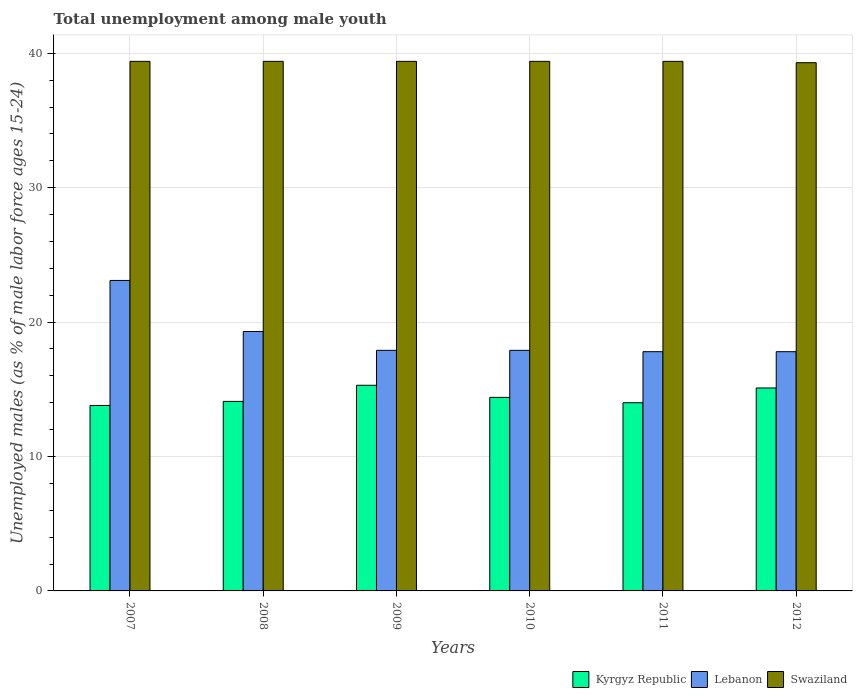How many different coloured bars are there?
Make the answer very short. 3. How many groups of bars are there?
Your answer should be compact. 6. How many bars are there on the 1st tick from the left?
Offer a terse response. 3. What is the percentage of unemployed males in in Kyrgyz Republic in 2010?
Your answer should be compact. 14.4. Across all years, what is the maximum percentage of unemployed males in in Swaziland?
Your response must be concise. 39.4. Across all years, what is the minimum percentage of unemployed males in in Lebanon?
Give a very brief answer. 17.8. In which year was the percentage of unemployed males in in Kyrgyz Republic maximum?
Offer a very short reply. 2009. What is the total percentage of unemployed males in in Kyrgyz Republic in the graph?
Provide a succinct answer. 86.7. What is the difference between the percentage of unemployed males in in Kyrgyz Republic in 2007 and the percentage of unemployed males in in Swaziland in 2012?
Your response must be concise. -25.5. What is the average percentage of unemployed males in in Swaziland per year?
Keep it short and to the point. 39.38. In the year 2010, what is the difference between the percentage of unemployed males in in Lebanon and percentage of unemployed males in in Swaziland?
Provide a succinct answer. -21.5. In how many years, is the percentage of unemployed males in in Swaziland greater than 18 %?
Provide a succinct answer. 6. What is the ratio of the percentage of unemployed males in in Kyrgyz Republic in 2007 to that in 2010?
Your response must be concise. 0.96. Is the percentage of unemployed males in in Lebanon in 2008 less than that in 2012?
Offer a terse response. No. What is the difference between the highest and the second highest percentage of unemployed males in in Kyrgyz Republic?
Keep it short and to the point. 0.2. What is the difference between the highest and the lowest percentage of unemployed males in in Lebanon?
Provide a short and direct response. 5.3. What does the 2nd bar from the left in 2009 represents?
Your answer should be very brief. Lebanon. What does the 1st bar from the right in 2008 represents?
Provide a short and direct response. Swaziland. Is it the case that in every year, the sum of the percentage of unemployed males in in Swaziland and percentage of unemployed males in in Lebanon is greater than the percentage of unemployed males in in Kyrgyz Republic?
Offer a very short reply. Yes. Are all the bars in the graph horizontal?
Offer a very short reply. No. What is the difference between two consecutive major ticks on the Y-axis?
Keep it short and to the point. 10. Are the values on the major ticks of Y-axis written in scientific E-notation?
Offer a very short reply. No. Does the graph contain any zero values?
Offer a very short reply. No. Where does the legend appear in the graph?
Provide a short and direct response. Bottom right. How are the legend labels stacked?
Ensure brevity in your answer.  Horizontal. What is the title of the graph?
Keep it short and to the point. Total unemployment among male youth. Does "Europe(developing only)" appear as one of the legend labels in the graph?
Offer a very short reply. No. What is the label or title of the X-axis?
Make the answer very short. Years. What is the label or title of the Y-axis?
Provide a succinct answer. Unemployed males (as % of male labor force ages 15-24). What is the Unemployed males (as % of male labor force ages 15-24) of Kyrgyz Republic in 2007?
Offer a very short reply. 13.8. What is the Unemployed males (as % of male labor force ages 15-24) in Lebanon in 2007?
Your answer should be compact. 23.1. What is the Unemployed males (as % of male labor force ages 15-24) in Swaziland in 2007?
Your answer should be very brief. 39.4. What is the Unemployed males (as % of male labor force ages 15-24) in Kyrgyz Republic in 2008?
Your answer should be compact. 14.1. What is the Unemployed males (as % of male labor force ages 15-24) of Lebanon in 2008?
Provide a succinct answer. 19.3. What is the Unemployed males (as % of male labor force ages 15-24) of Swaziland in 2008?
Ensure brevity in your answer.  39.4. What is the Unemployed males (as % of male labor force ages 15-24) of Kyrgyz Republic in 2009?
Ensure brevity in your answer.  15.3. What is the Unemployed males (as % of male labor force ages 15-24) of Lebanon in 2009?
Give a very brief answer. 17.9. What is the Unemployed males (as % of male labor force ages 15-24) of Swaziland in 2009?
Provide a short and direct response. 39.4. What is the Unemployed males (as % of male labor force ages 15-24) of Kyrgyz Republic in 2010?
Your response must be concise. 14.4. What is the Unemployed males (as % of male labor force ages 15-24) of Lebanon in 2010?
Make the answer very short. 17.9. What is the Unemployed males (as % of male labor force ages 15-24) of Swaziland in 2010?
Ensure brevity in your answer.  39.4. What is the Unemployed males (as % of male labor force ages 15-24) of Lebanon in 2011?
Ensure brevity in your answer.  17.8. What is the Unemployed males (as % of male labor force ages 15-24) of Swaziland in 2011?
Ensure brevity in your answer.  39.4. What is the Unemployed males (as % of male labor force ages 15-24) in Kyrgyz Republic in 2012?
Offer a very short reply. 15.1. What is the Unemployed males (as % of male labor force ages 15-24) in Lebanon in 2012?
Your response must be concise. 17.8. What is the Unemployed males (as % of male labor force ages 15-24) of Swaziland in 2012?
Your response must be concise. 39.3. Across all years, what is the maximum Unemployed males (as % of male labor force ages 15-24) of Kyrgyz Republic?
Your answer should be compact. 15.3. Across all years, what is the maximum Unemployed males (as % of male labor force ages 15-24) of Lebanon?
Ensure brevity in your answer.  23.1. Across all years, what is the maximum Unemployed males (as % of male labor force ages 15-24) in Swaziland?
Offer a terse response. 39.4. Across all years, what is the minimum Unemployed males (as % of male labor force ages 15-24) in Kyrgyz Republic?
Your response must be concise. 13.8. Across all years, what is the minimum Unemployed males (as % of male labor force ages 15-24) in Lebanon?
Keep it short and to the point. 17.8. Across all years, what is the minimum Unemployed males (as % of male labor force ages 15-24) of Swaziland?
Offer a terse response. 39.3. What is the total Unemployed males (as % of male labor force ages 15-24) of Kyrgyz Republic in the graph?
Provide a short and direct response. 86.7. What is the total Unemployed males (as % of male labor force ages 15-24) in Lebanon in the graph?
Your answer should be compact. 113.8. What is the total Unemployed males (as % of male labor force ages 15-24) of Swaziland in the graph?
Provide a short and direct response. 236.3. What is the difference between the Unemployed males (as % of male labor force ages 15-24) of Kyrgyz Republic in 2007 and that in 2008?
Make the answer very short. -0.3. What is the difference between the Unemployed males (as % of male labor force ages 15-24) of Lebanon in 2007 and that in 2008?
Offer a very short reply. 3.8. What is the difference between the Unemployed males (as % of male labor force ages 15-24) of Swaziland in 2007 and that in 2008?
Ensure brevity in your answer.  0. What is the difference between the Unemployed males (as % of male labor force ages 15-24) of Lebanon in 2007 and that in 2009?
Offer a very short reply. 5.2. What is the difference between the Unemployed males (as % of male labor force ages 15-24) in Swaziland in 2007 and that in 2009?
Your answer should be very brief. 0. What is the difference between the Unemployed males (as % of male labor force ages 15-24) in Kyrgyz Republic in 2007 and that in 2010?
Your answer should be very brief. -0.6. What is the difference between the Unemployed males (as % of male labor force ages 15-24) in Lebanon in 2007 and that in 2010?
Your answer should be compact. 5.2. What is the difference between the Unemployed males (as % of male labor force ages 15-24) of Swaziland in 2007 and that in 2012?
Keep it short and to the point. 0.1. What is the difference between the Unemployed males (as % of male labor force ages 15-24) in Kyrgyz Republic in 2008 and that in 2009?
Your answer should be very brief. -1.2. What is the difference between the Unemployed males (as % of male labor force ages 15-24) of Swaziland in 2008 and that in 2009?
Provide a succinct answer. 0. What is the difference between the Unemployed males (as % of male labor force ages 15-24) of Kyrgyz Republic in 2008 and that in 2010?
Ensure brevity in your answer.  -0.3. What is the difference between the Unemployed males (as % of male labor force ages 15-24) of Lebanon in 2008 and that in 2010?
Ensure brevity in your answer.  1.4. What is the difference between the Unemployed males (as % of male labor force ages 15-24) in Lebanon in 2008 and that in 2011?
Provide a succinct answer. 1.5. What is the difference between the Unemployed males (as % of male labor force ages 15-24) in Swaziland in 2008 and that in 2011?
Offer a very short reply. 0. What is the difference between the Unemployed males (as % of male labor force ages 15-24) in Kyrgyz Republic in 2008 and that in 2012?
Your answer should be compact. -1. What is the difference between the Unemployed males (as % of male labor force ages 15-24) of Kyrgyz Republic in 2009 and that in 2010?
Provide a succinct answer. 0.9. What is the difference between the Unemployed males (as % of male labor force ages 15-24) in Swaziland in 2009 and that in 2010?
Provide a succinct answer. 0. What is the difference between the Unemployed males (as % of male labor force ages 15-24) in Kyrgyz Republic in 2009 and that in 2011?
Give a very brief answer. 1.3. What is the difference between the Unemployed males (as % of male labor force ages 15-24) of Lebanon in 2009 and that in 2011?
Provide a succinct answer. 0.1. What is the difference between the Unemployed males (as % of male labor force ages 15-24) in Kyrgyz Republic in 2009 and that in 2012?
Your response must be concise. 0.2. What is the difference between the Unemployed males (as % of male labor force ages 15-24) of Lebanon in 2009 and that in 2012?
Your answer should be compact. 0.1. What is the difference between the Unemployed males (as % of male labor force ages 15-24) in Swaziland in 2009 and that in 2012?
Your answer should be very brief. 0.1. What is the difference between the Unemployed males (as % of male labor force ages 15-24) of Kyrgyz Republic in 2010 and that in 2011?
Your answer should be very brief. 0.4. What is the difference between the Unemployed males (as % of male labor force ages 15-24) in Kyrgyz Republic in 2010 and that in 2012?
Offer a very short reply. -0.7. What is the difference between the Unemployed males (as % of male labor force ages 15-24) in Lebanon in 2010 and that in 2012?
Provide a short and direct response. 0.1. What is the difference between the Unemployed males (as % of male labor force ages 15-24) in Swaziland in 2010 and that in 2012?
Your response must be concise. 0.1. What is the difference between the Unemployed males (as % of male labor force ages 15-24) of Kyrgyz Republic in 2007 and the Unemployed males (as % of male labor force ages 15-24) of Swaziland in 2008?
Your response must be concise. -25.6. What is the difference between the Unemployed males (as % of male labor force ages 15-24) of Lebanon in 2007 and the Unemployed males (as % of male labor force ages 15-24) of Swaziland in 2008?
Your answer should be compact. -16.3. What is the difference between the Unemployed males (as % of male labor force ages 15-24) of Kyrgyz Republic in 2007 and the Unemployed males (as % of male labor force ages 15-24) of Swaziland in 2009?
Offer a very short reply. -25.6. What is the difference between the Unemployed males (as % of male labor force ages 15-24) in Lebanon in 2007 and the Unemployed males (as % of male labor force ages 15-24) in Swaziland in 2009?
Your response must be concise. -16.3. What is the difference between the Unemployed males (as % of male labor force ages 15-24) of Kyrgyz Republic in 2007 and the Unemployed males (as % of male labor force ages 15-24) of Lebanon in 2010?
Give a very brief answer. -4.1. What is the difference between the Unemployed males (as % of male labor force ages 15-24) of Kyrgyz Republic in 2007 and the Unemployed males (as % of male labor force ages 15-24) of Swaziland in 2010?
Ensure brevity in your answer.  -25.6. What is the difference between the Unemployed males (as % of male labor force ages 15-24) of Lebanon in 2007 and the Unemployed males (as % of male labor force ages 15-24) of Swaziland in 2010?
Your answer should be very brief. -16.3. What is the difference between the Unemployed males (as % of male labor force ages 15-24) in Kyrgyz Republic in 2007 and the Unemployed males (as % of male labor force ages 15-24) in Lebanon in 2011?
Offer a terse response. -4. What is the difference between the Unemployed males (as % of male labor force ages 15-24) in Kyrgyz Republic in 2007 and the Unemployed males (as % of male labor force ages 15-24) in Swaziland in 2011?
Your answer should be compact. -25.6. What is the difference between the Unemployed males (as % of male labor force ages 15-24) in Lebanon in 2007 and the Unemployed males (as % of male labor force ages 15-24) in Swaziland in 2011?
Offer a terse response. -16.3. What is the difference between the Unemployed males (as % of male labor force ages 15-24) in Kyrgyz Republic in 2007 and the Unemployed males (as % of male labor force ages 15-24) in Swaziland in 2012?
Ensure brevity in your answer.  -25.5. What is the difference between the Unemployed males (as % of male labor force ages 15-24) in Lebanon in 2007 and the Unemployed males (as % of male labor force ages 15-24) in Swaziland in 2012?
Your answer should be very brief. -16.2. What is the difference between the Unemployed males (as % of male labor force ages 15-24) in Kyrgyz Republic in 2008 and the Unemployed males (as % of male labor force ages 15-24) in Lebanon in 2009?
Give a very brief answer. -3.8. What is the difference between the Unemployed males (as % of male labor force ages 15-24) in Kyrgyz Republic in 2008 and the Unemployed males (as % of male labor force ages 15-24) in Swaziland in 2009?
Make the answer very short. -25.3. What is the difference between the Unemployed males (as % of male labor force ages 15-24) of Lebanon in 2008 and the Unemployed males (as % of male labor force ages 15-24) of Swaziland in 2009?
Ensure brevity in your answer.  -20.1. What is the difference between the Unemployed males (as % of male labor force ages 15-24) in Kyrgyz Republic in 2008 and the Unemployed males (as % of male labor force ages 15-24) in Lebanon in 2010?
Make the answer very short. -3.8. What is the difference between the Unemployed males (as % of male labor force ages 15-24) of Kyrgyz Republic in 2008 and the Unemployed males (as % of male labor force ages 15-24) of Swaziland in 2010?
Offer a very short reply. -25.3. What is the difference between the Unemployed males (as % of male labor force ages 15-24) in Lebanon in 2008 and the Unemployed males (as % of male labor force ages 15-24) in Swaziland in 2010?
Your response must be concise. -20.1. What is the difference between the Unemployed males (as % of male labor force ages 15-24) of Kyrgyz Republic in 2008 and the Unemployed males (as % of male labor force ages 15-24) of Swaziland in 2011?
Make the answer very short. -25.3. What is the difference between the Unemployed males (as % of male labor force ages 15-24) of Lebanon in 2008 and the Unemployed males (as % of male labor force ages 15-24) of Swaziland in 2011?
Give a very brief answer. -20.1. What is the difference between the Unemployed males (as % of male labor force ages 15-24) in Kyrgyz Republic in 2008 and the Unemployed males (as % of male labor force ages 15-24) in Swaziland in 2012?
Your answer should be compact. -25.2. What is the difference between the Unemployed males (as % of male labor force ages 15-24) of Kyrgyz Republic in 2009 and the Unemployed males (as % of male labor force ages 15-24) of Swaziland in 2010?
Offer a very short reply. -24.1. What is the difference between the Unemployed males (as % of male labor force ages 15-24) in Lebanon in 2009 and the Unemployed males (as % of male labor force ages 15-24) in Swaziland in 2010?
Provide a short and direct response. -21.5. What is the difference between the Unemployed males (as % of male labor force ages 15-24) of Kyrgyz Republic in 2009 and the Unemployed males (as % of male labor force ages 15-24) of Swaziland in 2011?
Make the answer very short. -24.1. What is the difference between the Unemployed males (as % of male labor force ages 15-24) in Lebanon in 2009 and the Unemployed males (as % of male labor force ages 15-24) in Swaziland in 2011?
Offer a terse response. -21.5. What is the difference between the Unemployed males (as % of male labor force ages 15-24) in Kyrgyz Republic in 2009 and the Unemployed males (as % of male labor force ages 15-24) in Lebanon in 2012?
Offer a very short reply. -2.5. What is the difference between the Unemployed males (as % of male labor force ages 15-24) in Kyrgyz Republic in 2009 and the Unemployed males (as % of male labor force ages 15-24) in Swaziland in 2012?
Your answer should be compact. -24. What is the difference between the Unemployed males (as % of male labor force ages 15-24) in Lebanon in 2009 and the Unemployed males (as % of male labor force ages 15-24) in Swaziland in 2012?
Your response must be concise. -21.4. What is the difference between the Unemployed males (as % of male labor force ages 15-24) of Lebanon in 2010 and the Unemployed males (as % of male labor force ages 15-24) of Swaziland in 2011?
Your response must be concise. -21.5. What is the difference between the Unemployed males (as % of male labor force ages 15-24) of Kyrgyz Republic in 2010 and the Unemployed males (as % of male labor force ages 15-24) of Lebanon in 2012?
Provide a succinct answer. -3.4. What is the difference between the Unemployed males (as % of male labor force ages 15-24) of Kyrgyz Republic in 2010 and the Unemployed males (as % of male labor force ages 15-24) of Swaziland in 2012?
Give a very brief answer. -24.9. What is the difference between the Unemployed males (as % of male labor force ages 15-24) of Lebanon in 2010 and the Unemployed males (as % of male labor force ages 15-24) of Swaziland in 2012?
Provide a succinct answer. -21.4. What is the difference between the Unemployed males (as % of male labor force ages 15-24) in Kyrgyz Republic in 2011 and the Unemployed males (as % of male labor force ages 15-24) in Lebanon in 2012?
Your answer should be compact. -3.8. What is the difference between the Unemployed males (as % of male labor force ages 15-24) of Kyrgyz Republic in 2011 and the Unemployed males (as % of male labor force ages 15-24) of Swaziland in 2012?
Your answer should be compact. -25.3. What is the difference between the Unemployed males (as % of male labor force ages 15-24) in Lebanon in 2011 and the Unemployed males (as % of male labor force ages 15-24) in Swaziland in 2012?
Your answer should be compact. -21.5. What is the average Unemployed males (as % of male labor force ages 15-24) in Kyrgyz Republic per year?
Provide a succinct answer. 14.45. What is the average Unemployed males (as % of male labor force ages 15-24) of Lebanon per year?
Provide a succinct answer. 18.97. What is the average Unemployed males (as % of male labor force ages 15-24) in Swaziland per year?
Offer a very short reply. 39.38. In the year 2007, what is the difference between the Unemployed males (as % of male labor force ages 15-24) in Kyrgyz Republic and Unemployed males (as % of male labor force ages 15-24) in Lebanon?
Your answer should be very brief. -9.3. In the year 2007, what is the difference between the Unemployed males (as % of male labor force ages 15-24) in Kyrgyz Republic and Unemployed males (as % of male labor force ages 15-24) in Swaziland?
Offer a very short reply. -25.6. In the year 2007, what is the difference between the Unemployed males (as % of male labor force ages 15-24) of Lebanon and Unemployed males (as % of male labor force ages 15-24) of Swaziland?
Ensure brevity in your answer.  -16.3. In the year 2008, what is the difference between the Unemployed males (as % of male labor force ages 15-24) of Kyrgyz Republic and Unemployed males (as % of male labor force ages 15-24) of Swaziland?
Provide a short and direct response. -25.3. In the year 2008, what is the difference between the Unemployed males (as % of male labor force ages 15-24) in Lebanon and Unemployed males (as % of male labor force ages 15-24) in Swaziland?
Keep it short and to the point. -20.1. In the year 2009, what is the difference between the Unemployed males (as % of male labor force ages 15-24) of Kyrgyz Republic and Unemployed males (as % of male labor force ages 15-24) of Lebanon?
Your response must be concise. -2.6. In the year 2009, what is the difference between the Unemployed males (as % of male labor force ages 15-24) of Kyrgyz Republic and Unemployed males (as % of male labor force ages 15-24) of Swaziland?
Your answer should be compact. -24.1. In the year 2009, what is the difference between the Unemployed males (as % of male labor force ages 15-24) of Lebanon and Unemployed males (as % of male labor force ages 15-24) of Swaziland?
Your answer should be compact. -21.5. In the year 2010, what is the difference between the Unemployed males (as % of male labor force ages 15-24) in Kyrgyz Republic and Unemployed males (as % of male labor force ages 15-24) in Lebanon?
Keep it short and to the point. -3.5. In the year 2010, what is the difference between the Unemployed males (as % of male labor force ages 15-24) in Lebanon and Unemployed males (as % of male labor force ages 15-24) in Swaziland?
Your answer should be very brief. -21.5. In the year 2011, what is the difference between the Unemployed males (as % of male labor force ages 15-24) of Kyrgyz Republic and Unemployed males (as % of male labor force ages 15-24) of Lebanon?
Keep it short and to the point. -3.8. In the year 2011, what is the difference between the Unemployed males (as % of male labor force ages 15-24) in Kyrgyz Republic and Unemployed males (as % of male labor force ages 15-24) in Swaziland?
Make the answer very short. -25.4. In the year 2011, what is the difference between the Unemployed males (as % of male labor force ages 15-24) of Lebanon and Unemployed males (as % of male labor force ages 15-24) of Swaziland?
Your answer should be compact. -21.6. In the year 2012, what is the difference between the Unemployed males (as % of male labor force ages 15-24) of Kyrgyz Republic and Unemployed males (as % of male labor force ages 15-24) of Lebanon?
Offer a very short reply. -2.7. In the year 2012, what is the difference between the Unemployed males (as % of male labor force ages 15-24) of Kyrgyz Republic and Unemployed males (as % of male labor force ages 15-24) of Swaziland?
Offer a very short reply. -24.2. In the year 2012, what is the difference between the Unemployed males (as % of male labor force ages 15-24) of Lebanon and Unemployed males (as % of male labor force ages 15-24) of Swaziland?
Keep it short and to the point. -21.5. What is the ratio of the Unemployed males (as % of male labor force ages 15-24) in Kyrgyz Republic in 2007 to that in 2008?
Ensure brevity in your answer.  0.98. What is the ratio of the Unemployed males (as % of male labor force ages 15-24) in Lebanon in 2007 to that in 2008?
Provide a succinct answer. 1.2. What is the ratio of the Unemployed males (as % of male labor force ages 15-24) of Swaziland in 2007 to that in 2008?
Offer a terse response. 1. What is the ratio of the Unemployed males (as % of male labor force ages 15-24) of Kyrgyz Republic in 2007 to that in 2009?
Provide a short and direct response. 0.9. What is the ratio of the Unemployed males (as % of male labor force ages 15-24) in Lebanon in 2007 to that in 2009?
Ensure brevity in your answer.  1.29. What is the ratio of the Unemployed males (as % of male labor force ages 15-24) of Lebanon in 2007 to that in 2010?
Provide a succinct answer. 1.29. What is the ratio of the Unemployed males (as % of male labor force ages 15-24) in Swaziland in 2007 to that in 2010?
Offer a very short reply. 1. What is the ratio of the Unemployed males (as % of male labor force ages 15-24) of Kyrgyz Republic in 2007 to that in 2011?
Your answer should be very brief. 0.99. What is the ratio of the Unemployed males (as % of male labor force ages 15-24) of Lebanon in 2007 to that in 2011?
Provide a succinct answer. 1.3. What is the ratio of the Unemployed males (as % of male labor force ages 15-24) of Kyrgyz Republic in 2007 to that in 2012?
Provide a short and direct response. 0.91. What is the ratio of the Unemployed males (as % of male labor force ages 15-24) of Lebanon in 2007 to that in 2012?
Offer a terse response. 1.3. What is the ratio of the Unemployed males (as % of male labor force ages 15-24) of Swaziland in 2007 to that in 2012?
Provide a short and direct response. 1. What is the ratio of the Unemployed males (as % of male labor force ages 15-24) of Kyrgyz Republic in 2008 to that in 2009?
Provide a short and direct response. 0.92. What is the ratio of the Unemployed males (as % of male labor force ages 15-24) of Lebanon in 2008 to that in 2009?
Provide a short and direct response. 1.08. What is the ratio of the Unemployed males (as % of male labor force ages 15-24) of Kyrgyz Republic in 2008 to that in 2010?
Your answer should be compact. 0.98. What is the ratio of the Unemployed males (as % of male labor force ages 15-24) of Lebanon in 2008 to that in 2010?
Provide a short and direct response. 1.08. What is the ratio of the Unemployed males (as % of male labor force ages 15-24) of Swaziland in 2008 to that in 2010?
Offer a very short reply. 1. What is the ratio of the Unemployed males (as % of male labor force ages 15-24) in Kyrgyz Republic in 2008 to that in 2011?
Your response must be concise. 1.01. What is the ratio of the Unemployed males (as % of male labor force ages 15-24) in Lebanon in 2008 to that in 2011?
Offer a very short reply. 1.08. What is the ratio of the Unemployed males (as % of male labor force ages 15-24) in Swaziland in 2008 to that in 2011?
Provide a short and direct response. 1. What is the ratio of the Unemployed males (as % of male labor force ages 15-24) in Kyrgyz Republic in 2008 to that in 2012?
Give a very brief answer. 0.93. What is the ratio of the Unemployed males (as % of male labor force ages 15-24) in Lebanon in 2008 to that in 2012?
Provide a succinct answer. 1.08. What is the ratio of the Unemployed males (as % of male labor force ages 15-24) of Swaziland in 2008 to that in 2012?
Ensure brevity in your answer.  1. What is the ratio of the Unemployed males (as % of male labor force ages 15-24) in Kyrgyz Republic in 2009 to that in 2010?
Offer a terse response. 1.06. What is the ratio of the Unemployed males (as % of male labor force ages 15-24) of Kyrgyz Republic in 2009 to that in 2011?
Provide a short and direct response. 1.09. What is the ratio of the Unemployed males (as % of male labor force ages 15-24) in Lebanon in 2009 to that in 2011?
Your answer should be compact. 1.01. What is the ratio of the Unemployed males (as % of male labor force ages 15-24) in Kyrgyz Republic in 2009 to that in 2012?
Your response must be concise. 1.01. What is the ratio of the Unemployed males (as % of male labor force ages 15-24) of Lebanon in 2009 to that in 2012?
Make the answer very short. 1.01. What is the ratio of the Unemployed males (as % of male labor force ages 15-24) of Kyrgyz Republic in 2010 to that in 2011?
Keep it short and to the point. 1.03. What is the ratio of the Unemployed males (as % of male labor force ages 15-24) of Lebanon in 2010 to that in 2011?
Your answer should be compact. 1.01. What is the ratio of the Unemployed males (as % of male labor force ages 15-24) of Swaziland in 2010 to that in 2011?
Provide a short and direct response. 1. What is the ratio of the Unemployed males (as % of male labor force ages 15-24) in Kyrgyz Republic in 2010 to that in 2012?
Provide a succinct answer. 0.95. What is the ratio of the Unemployed males (as % of male labor force ages 15-24) in Lebanon in 2010 to that in 2012?
Provide a succinct answer. 1.01. What is the ratio of the Unemployed males (as % of male labor force ages 15-24) of Swaziland in 2010 to that in 2012?
Provide a succinct answer. 1. What is the ratio of the Unemployed males (as % of male labor force ages 15-24) in Kyrgyz Republic in 2011 to that in 2012?
Your answer should be compact. 0.93. What is the difference between the highest and the second highest Unemployed males (as % of male labor force ages 15-24) in Lebanon?
Offer a terse response. 3.8. What is the difference between the highest and the second highest Unemployed males (as % of male labor force ages 15-24) in Swaziland?
Keep it short and to the point. 0. What is the difference between the highest and the lowest Unemployed males (as % of male labor force ages 15-24) of Kyrgyz Republic?
Your answer should be very brief. 1.5. What is the difference between the highest and the lowest Unemployed males (as % of male labor force ages 15-24) of Lebanon?
Your answer should be very brief. 5.3. What is the difference between the highest and the lowest Unemployed males (as % of male labor force ages 15-24) in Swaziland?
Provide a succinct answer. 0.1. 